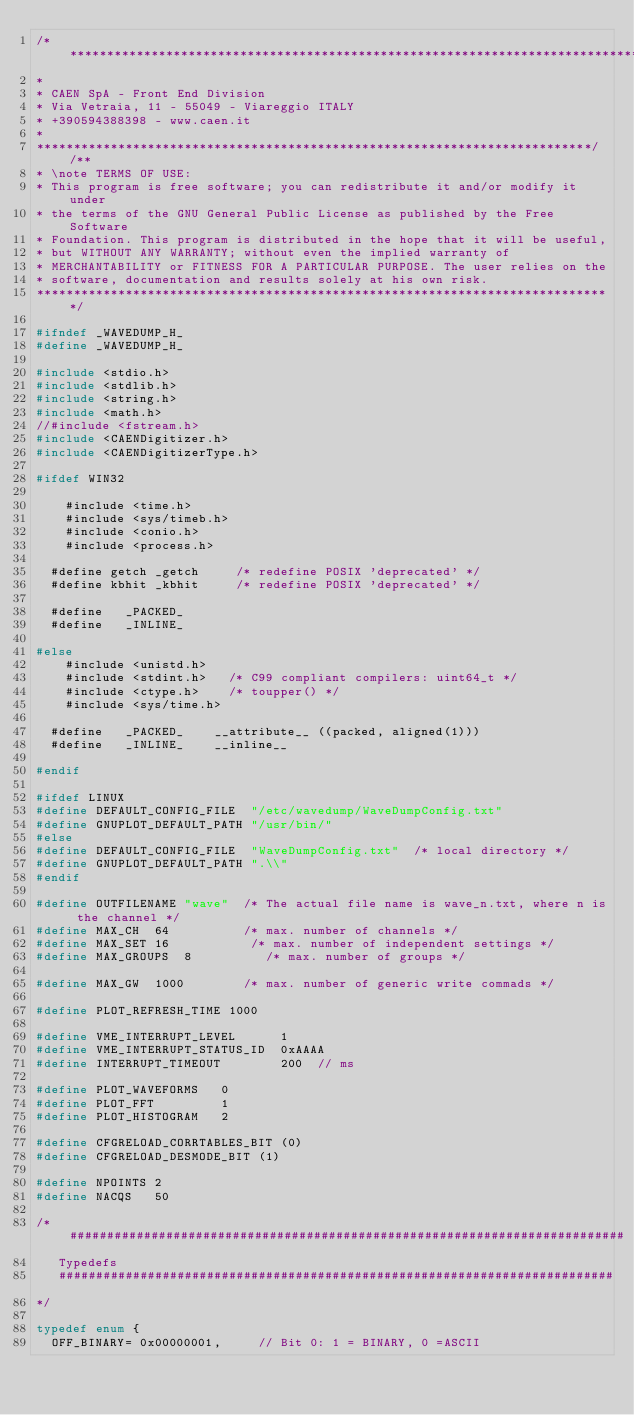<code> <loc_0><loc_0><loc_500><loc_500><_C_>/******************************************************************************
* 
* CAEN SpA - Front End Division
* Via Vetraia, 11 - 55049 - Viareggio ITALY
* +390594388398 - www.caen.it
*
***************************************************************************//**
* \note TERMS OF USE:
* This program is free software; you can redistribute it and/or modify it under
* the terms of the GNU General Public License as published by the Free Software
* Foundation. This program is distributed in the hope that it will be useful, 
* but WITHOUT ANY WARRANTY; without even the implied warranty of 
* MERCHANTABILITY or FITNESS FOR A PARTICULAR PURPOSE. The user relies on the 
* software, documentation and results solely at his own risk.
******************************************************************************/

#ifndef _WAVEDUMP_H_
#define _WAVEDUMP_H_

#include <stdio.h>
#include <stdlib.h>
#include <string.h>
#include <math.h>
//#include <fstream.h>
#include <CAENDigitizer.h>
#include <CAENDigitizerType.h>

#ifdef WIN32

    #include <time.h>
    #include <sys/timeb.h>
    #include <conio.h>
    #include <process.h>

	#define getch _getch     /* redefine POSIX 'deprecated' */
	#define kbhit _kbhit     /* redefine POSIX 'deprecated' */

	#define		_PACKED_
	#define		_INLINE_		

#else
    #include <unistd.h>
    #include <stdint.h>   /* C99 compliant compilers: uint64_t */
    #include <ctype.h>    /* toupper() */
    #include <sys/time.h>

	#define		_PACKED_		__attribute__ ((packed, aligned(1)))
	#define		_INLINE_		__inline__ 

#endif

#ifdef LINUX
#define DEFAULT_CONFIG_FILE  "/etc/wavedump/WaveDumpConfig.txt"
#define GNUPLOT_DEFAULT_PATH "/usr/bin/"
#else
#define DEFAULT_CONFIG_FILE  "WaveDumpConfig.txt"  /* local directory */
#define GNUPLOT_DEFAULT_PATH ".\\"
#endif

#define OUTFILENAME "wave"  /* The actual file name is wave_n.txt, where n is the channel */
#define MAX_CH  64          /* max. number of channels */
#define MAX_SET 16           /* max. number of independent settings */
#define MAX_GROUPS  8          /* max. number of groups */

#define MAX_GW  1000        /* max. number of generic write commads */

#define PLOT_REFRESH_TIME 1000

#define VME_INTERRUPT_LEVEL      1
#define VME_INTERRUPT_STATUS_ID  0xAAAA
#define INTERRUPT_TIMEOUT        200  // ms
        
#define PLOT_WAVEFORMS   0
#define PLOT_FFT         1
#define PLOT_HISTOGRAM   2

#define CFGRELOAD_CORRTABLES_BIT (0)
#define CFGRELOAD_DESMODE_BIT (1)

#define NPOINTS 2
#define NACQS   50

/* ###########################################################################
   Typedefs
   ###########################################################################
*/

typedef enum {
	OFF_BINARY=	0x00000001,			// Bit 0: 1 = BINARY, 0 =ASCII</code> 